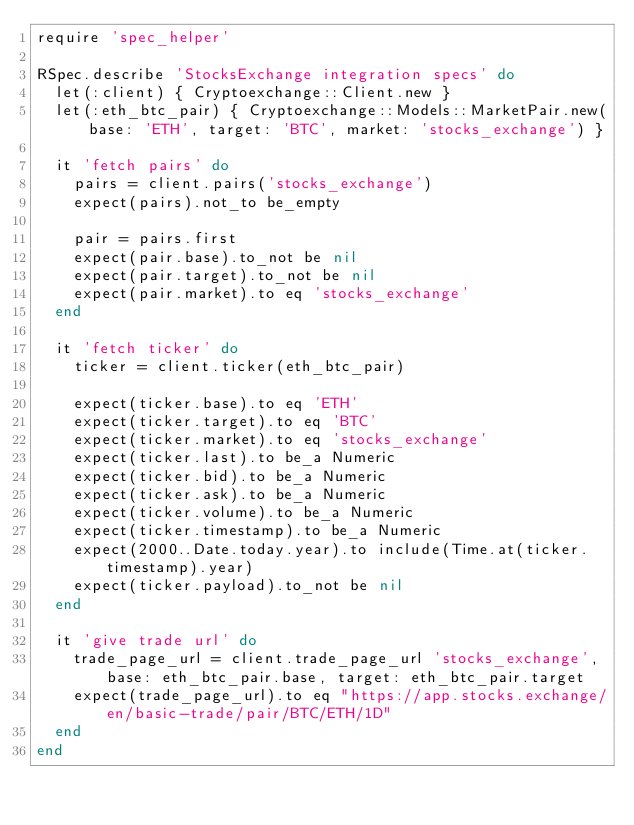Convert code to text. <code><loc_0><loc_0><loc_500><loc_500><_Ruby_>require 'spec_helper'

RSpec.describe 'StocksExchange integration specs' do
  let(:client) { Cryptoexchange::Client.new }
  let(:eth_btc_pair) { Cryptoexchange::Models::MarketPair.new(base: 'ETH', target: 'BTC', market: 'stocks_exchange') }

  it 'fetch pairs' do
    pairs = client.pairs('stocks_exchange')
    expect(pairs).not_to be_empty

    pair = pairs.first
    expect(pair.base).to_not be nil
    expect(pair.target).to_not be nil
    expect(pair.market).to eq 'stocks_exchange'
  end

  it 'fetch ticker' do
    ticker = client.ticker(eth_btc_pair)

    expect(ticker.base).to eq 'ETH'
    expect(ticker.target).to eq 'BTC'
    expect(ticker.market).to eq 'stocks_exchange'
    expect(ticker.last).to be_a Numeric
    expect(ticker.bid).to be_a Numeric
    expect(ticker.ask).to be_a Numeric
    expect(ticker.volume).to be_a Numeric
    expect(ticker.timestamp).to be_a Numeric
    expect(2000..Date.today.year).to include(Time.at(ticker.timestamp).year)
    expect(ticker.payload).to_not be nil
  end

  it 'give trade url' do
    trade_page_url = client.trade_page_url 'stocks_exchange', base: eth_btc_pair.base, target: eth_btc_pair.target
    expect(trade_page_url).to eq "https://app.stocks.exchange/en/basic-trade/pair/BTC/ETH/1D"
  end
end
</code> 